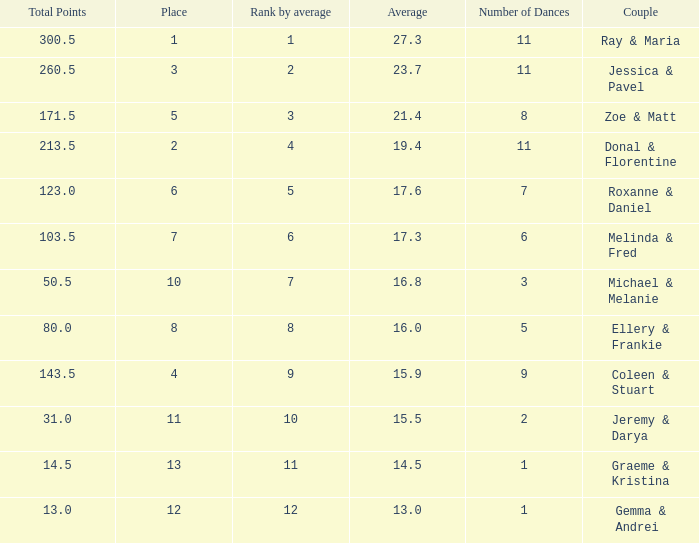What place would you be in if your rank by average is less than 2.0? 1.0. 